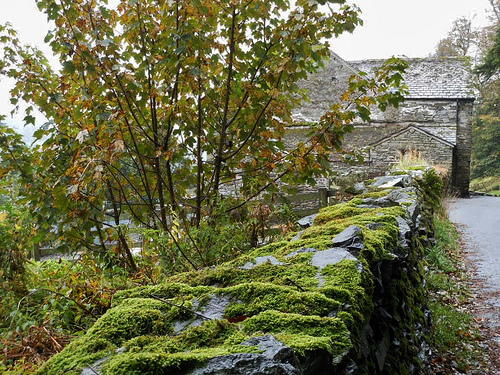<image>
Is there a house in front of the tree? No. The house is not in front of the tree. The spatial positioning shows a different relationship between these objects. 